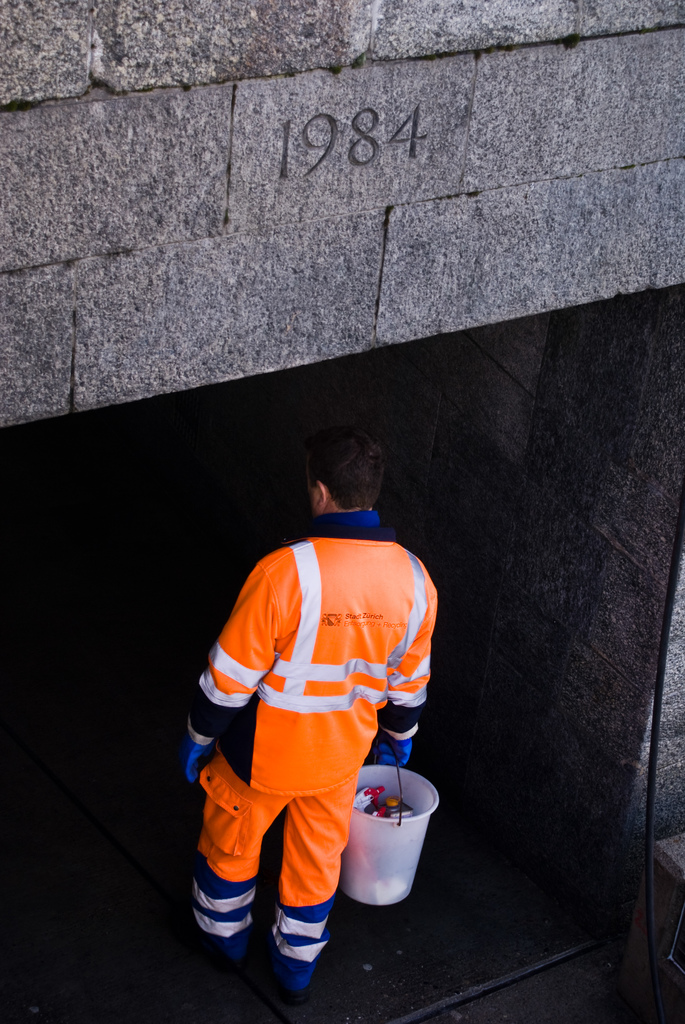What might the worker be preparing to do in the tunnel? The worker, dressed in Stadt Zurich maintenance gear, appears to be entering the tunnel for a routine inspection or cleaning task, possibly dealing with the city's utility or drainage systems. Is there anything significant about the year 1984 marked on the tunnel? The year 1984 could signify the year of construction or a commemorative event related to the tunnel, providing historical context that might interest municipal historians or local residents. 